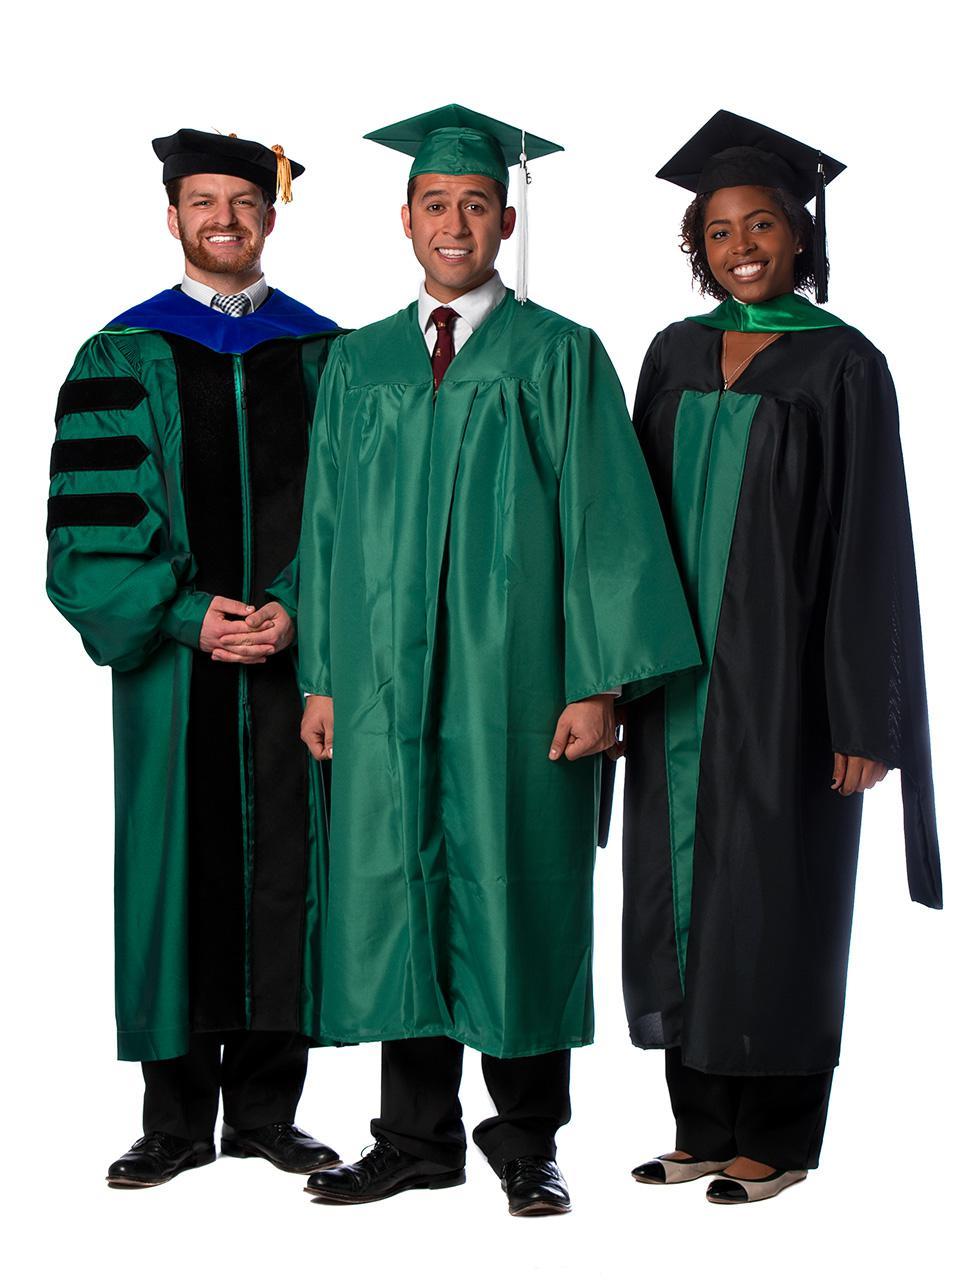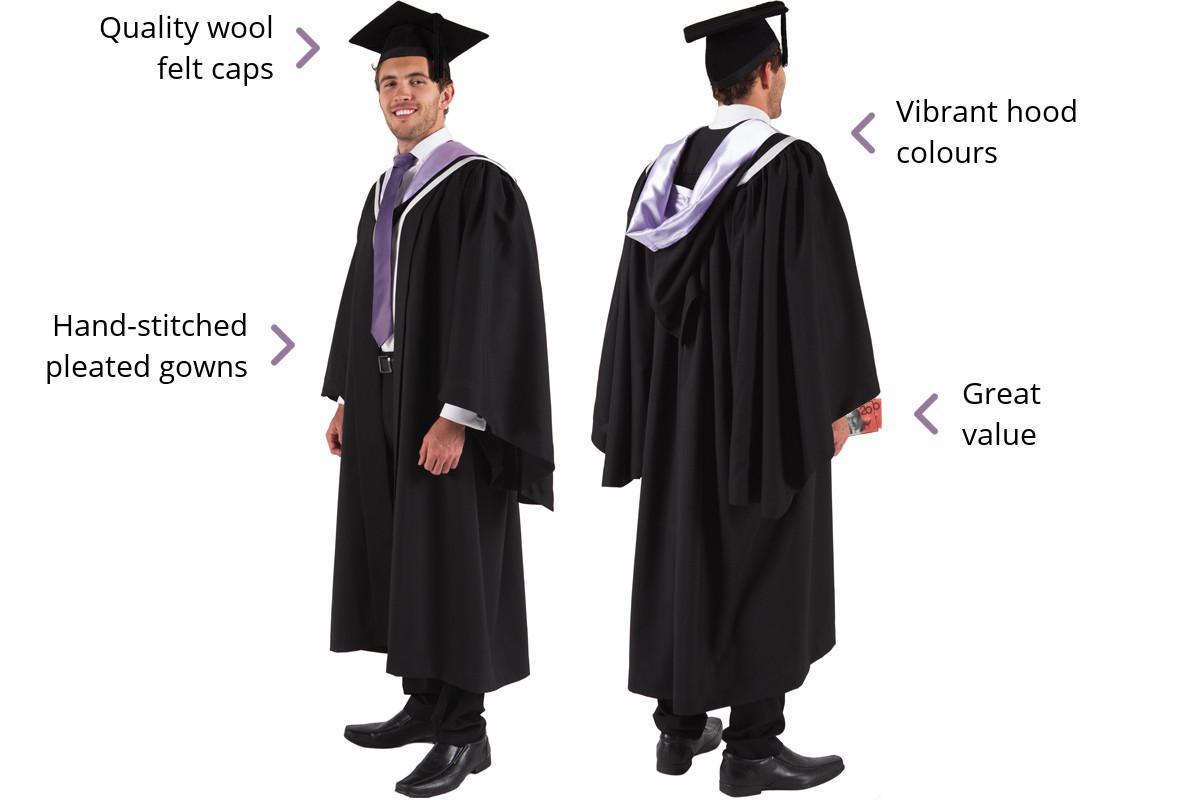The first image is the image on the left, the second image is the image on the right. For the images shown, is this caption "At least one image shows only a female graduate." true? Answer yes or no. No. The first image is the image on the left, the second image is the image on the right. Examine the images to the left and right. Is the description "All graduation gown models are one gender." accurate? Answer yes or no. No. The first image is the image on the left, the second image is the image on the right. For the images shown, is this caption "There are three people in one of the images." true? Answer yes or no. Yes. 